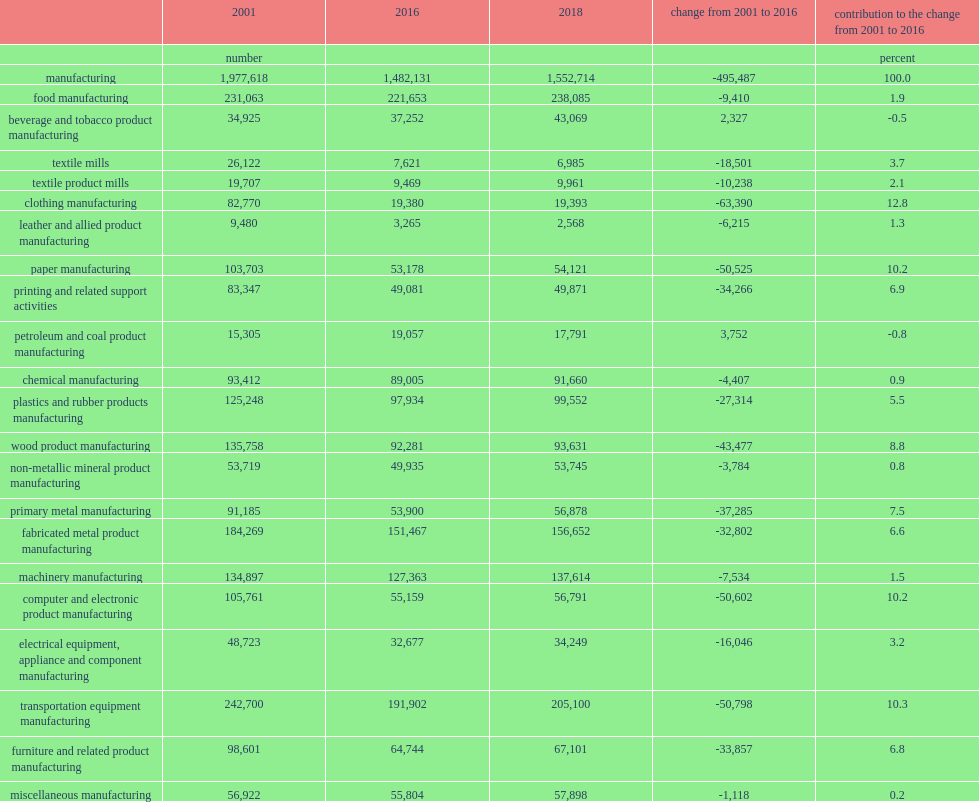From 2001 to 2016, what was the number of canadian employees working in manufacturing fell by roughly half a million dropped in 2001? 1977618.0. From 2001 to 2016, what was the number of canadian employees working in manufacturing fell by roughly half a million dropped to in 2016? 1482131.0. Can you parse all the data within this table? {'header': ['', '2001', '2016', '2018', 'change from 2001 to 2016', 'contribution to the change from 2001 to 2016'], 'rows': [['', 'number', '', '', '', 'percent'], ['manufacturing', '1,977,618', '1,482,131', '1,552,714', '-495,487', '100.0'], ['food manufacturing', '231,063', '221,653', '238,085', '-9,410', '1.9'], ['beverage and tobacco product manufacturing', '34,925', '37,252', '43,069', '2,327', '-0.5'], ['textile mills', '26,122', '7,621', '6,985', '-18,501', '3.7'], ['textile product mills', '19,707', '9,469', '9,961', '-10,238', '2.1'], ['clothing manufacturing', '82,770', '19,380', '19,393', '-63,390', '12.8'], ['leather and allied product manufacturing', '9,480', '3,265', '2,568', '-6,215', '1.3'], ['paper manufacturing', '103,703', '53,178', '54,121', '-50,525', '10.2'], ['printing and related support activities', '83,347', '49,081', '49,871', '-34,266', '6.9'], ['petroleum and coal product manufacturing', '15,305', '19,057', '17,791', '3,752', '-0.8'], ['chemical manufacturing', '93,412', '89,005', '91,660', '-4,407', '0.9'], ['plastics and rubber products manufacturing', '125,248', '97,934', '99,552', '-27,314', '5.5'], ['wood product manufacturing', '135,758', '92,281', '93,631', '-43,477', '8.8'], ['non-metallic mineral product manufacturing', '53,719', '49,935', '53,745', '-3,784', '0.8'], ['primary metal manufacturing', '91,185', '53,900', '56,878', '-37,285', '7.5'], ['fabricated metal product manufacturing', '184,269', '151,467', '156,652', '-32,802', '6.6'], ['machinery manufacturing', '134,897', '127,363', '137,614', '-7,534', '1.5'], ['computer and electronic product manufacturing', '105,761', '55,159', '56,791', '-50,602', '10.2'], ['electrical equipment, appliance and component manufacturing', '48,723', '32,677', '34,249', '-16,046', '3.2'], ['transportation equipment manufacturing', '242,700', '191,902', '205,100', '-50,798', '10.3'], ['furniture and related product manufacturing', '98,601', '64,744', '67,101', '-33,857', '6.8'], ['miscellaneous manufacturing', '56,922', '55,804', '57,898', '-1,118', '0.2']]} 